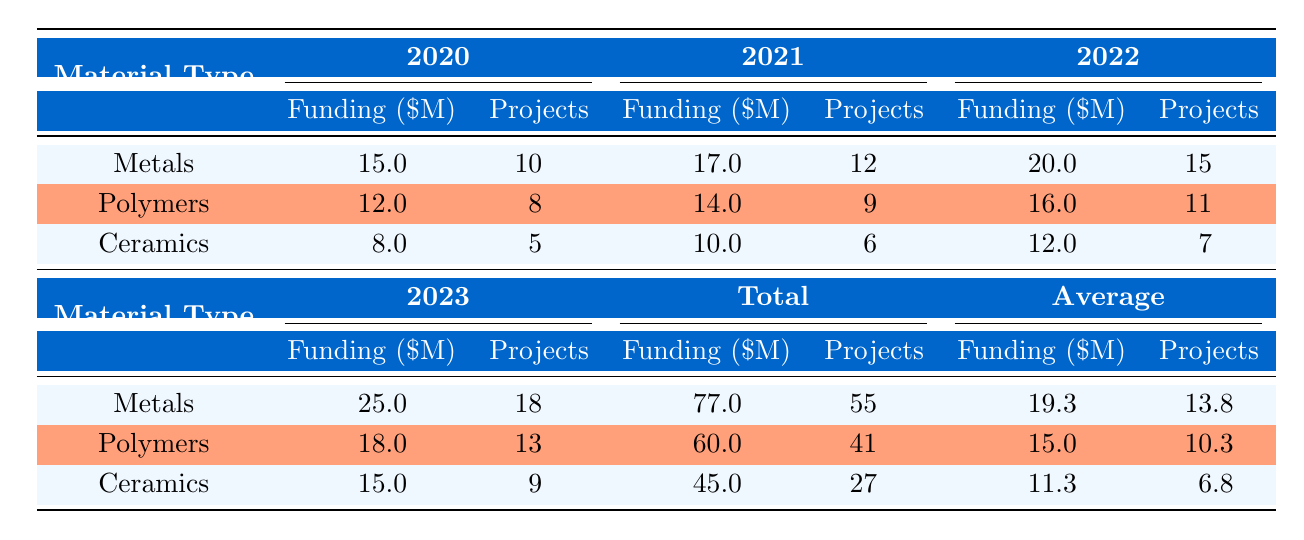What was the total funding allocated for Polymers in 2021? To find the total funding allocated for Polymers in 2021, we look at the specific row for Polymers under the 2021 column. The funding allocated is 14 million USD.
Answer: 14 million USD How much funding was allocated to Ceramics in 2022? We can directly see from the table that the funding allocated to Ceramics in 2022 is listed under the corresponding column, which shows 12 million USD.
Answer: 12 million USD What is the average funding allocated to Metals over the four years displayed? To calculate the average funding allocated to Metals, we sum the values: 15 + 17 + 20 + 25 = 77 million USD. Then, we divide this by the number of years, which is 4: 77/4 = 19.25 million USD.
Answer: 19.25 million USD Did the funding for Polymers increase every year from 2020 to 2023? To verify this, we compare the funding allocated for Polymers across each year: 12 million in 2020, 14 million in 2021, 16 million in 2022, and 18 million in 2023. Since each year's funding is greater than the previous one, it confirms that funding increased every year.
Answer: Yes What is the difference in the number of projects for Ceramics between 2020 and 2023? We check the number of projects for Ceramics for both years. In 2020, there were 5 projects, and in 2023, there were 9 projects. The difference is calculated as 9 - 5 = 4 projects.
Answer: 4 projects What was the total funding allocated for all material types in 2022? We sum the funding allocated for each material type in 2022: Metals (20 million) + Polymers (16 million) + Ceramics (12 million) = 48 million USD total funding allocated for all material types in that year.
Answer: 48 million USD Is the total funding allocated for Ceramics across all years more than 50 million USD? First, we sum the funding allocated to Ceramics for all the years: 8 (2020) + 10 (2021) + 12 (2022) + 15 (2023) = 45 million USD. Since 45 million is less than 50 million, the statement is false.
Answer: No What was the highest funding amount for any material type in a single year? Upon examining the funding amounts for each material type across the years, the highest funding amount was 25 million USD allocated to Metals in 2023.
Answer: 25 million USD 